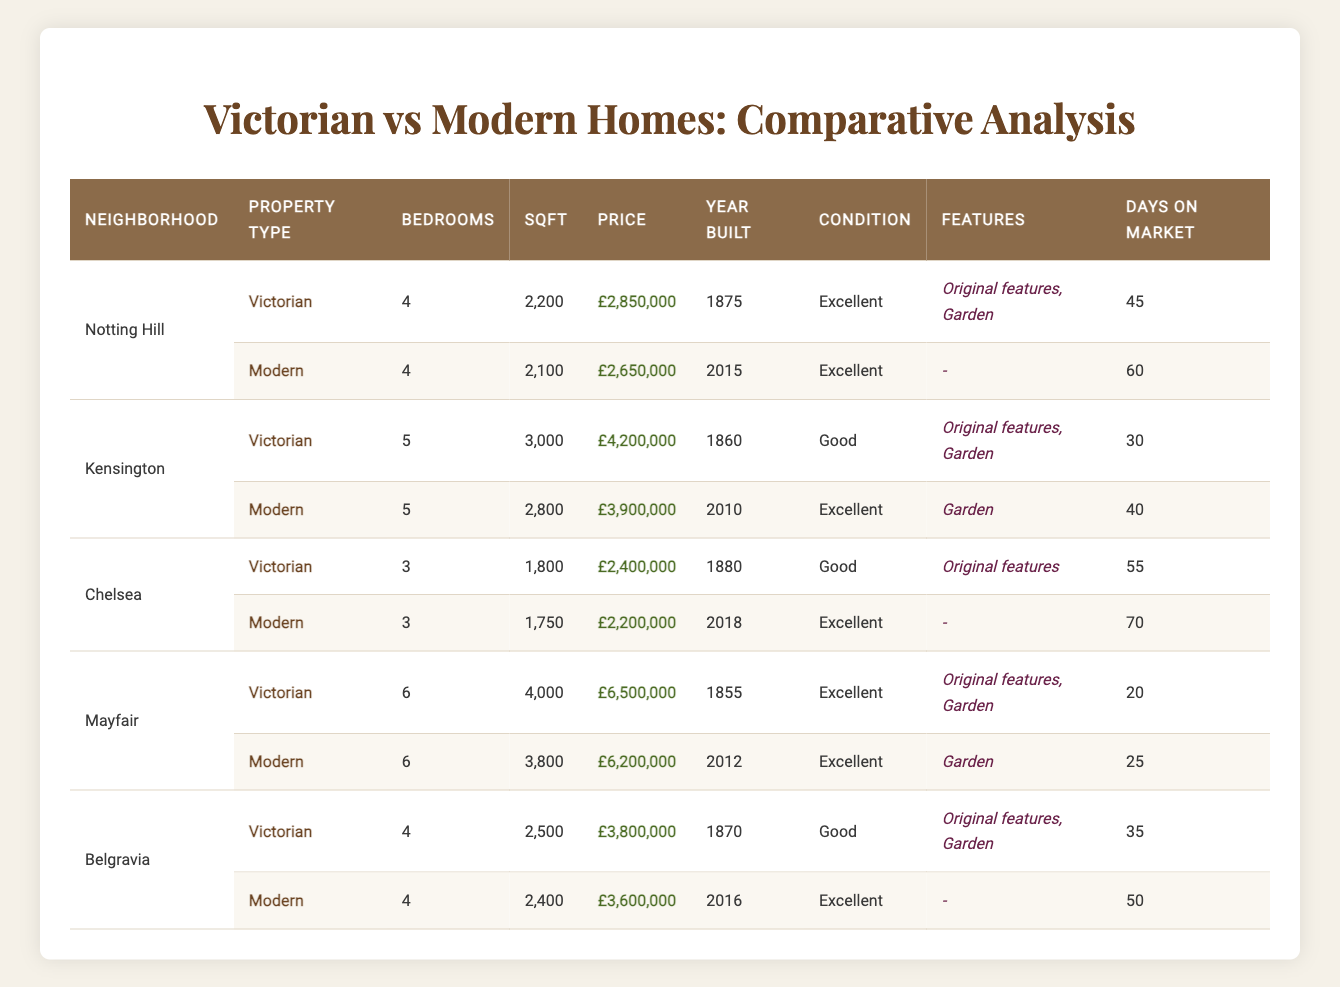What is the price of the Victorian home in Notting Hill? The price of the Victorian home in Notting Hill can be found directly in the table under the corresponding row. It shows £2,850,000.
Answer: £2,850,000 How many bedrooms does the Modern home in Chelsea have? By looking at the row for the Modern property in Chelsea, it lists that it has 3 bedrooms.
Answer: 3 Which property type has more listings in the Kensington neighborhood? In the Kensington neighborhood, the table shows two entries: one Victorian and one Modern. Both types are represented so there are equal listings.
Answer: Equal What is the total price difference between the Victorian and Modern homes in Mayfair? The Victorian home in Mayfair is priced at £6,500,000, while the Modern home is priced at £6,200,000. The price difference is calculated as £6,500,000 - £6,200,000 = £300,000.
Answer: £300,000 Are all Victorian houses listed in this table in excellent condition? By reviewing the "Condition" column for the Victorian houses, it shows that the one in Kensington is in "Good" condition, while others are "Excellent". Therefore, not all are in excellent condition.
Answer: No What is the average number of days on the market for Victorian homes compared to Modern homes? For Victorian homes, the days on market are 45 (Notting Hill), 30 (Kensington), 55 (Chelsea), 20 (Mayfair), and 35 (Belgravia). The sum is 185 and the average is 185/5 = 37. For Modern homes, the days are 60 (Notting Hill), 40 (Kensington), 70 (Chelsea), 25 (Mayfair), and 50 (Belgravia). The sum is 245 and the average is 245/5 = 49.
Answer: Victorian: 37, Modern: 49 Which neighborhood has the highest priced Victorian home? The highest priced Victorian home is listed under Mayfair with a price of £6,500,000. Comparing all neighborhoods, Mayfair has the highest figure.
Answer: Mayfair What proportion of properties in Belgravia have gardens? In Belgravia, both the Victorian and Modern homes are examined. The Victorian home states "Yes" for garden while the Modern home states "No". Therefore, 1 out of 2 properties have gardens, resulting in a proportion of 1/2 = 0.5.
Answer: 0.5 Which type of house has more original features based on the table? In the table, the Victorian homes are indicated to possess "Yes" for original features in all cases except for Chelsea. The Modern homes have "No" for all instances. Since 3 out of 5 Victorian homes have original features while Modern homes have none, Victorian houses have more original features overall.
Answer: Victorian homes 